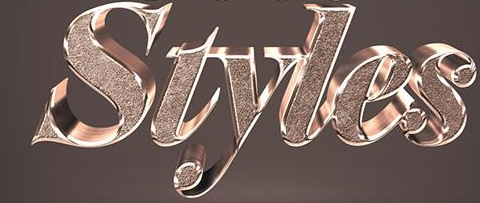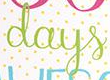What words can you see in these images in sequence, separated by a semicolon? Styles; days 